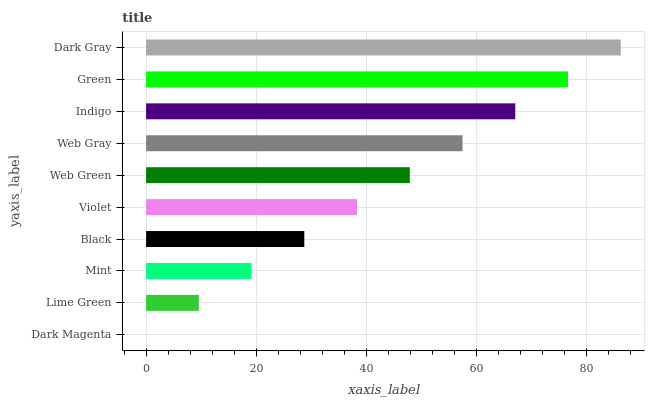Is Dark Magenta the minimum?
Answer yes or no. Yes. Is Dark Gray the maximum?
Answer yes or no. Yes. Is Lime Green the minimum?
Answer yes or no. No. Is Lime Green the maximum?
Answer yes or no. No. Is Lime Green greater than Dark Magenta?
Answer yes or no. Yes. Is Dark Magenta less than Lime Green?
Answer yes or no. Yes. Is Dark Magenta greater than Lime Green?
Answer yes or no. No. Is Lime Green less than Dark Magenta?
Answer yes or no. No. Is Web Green the high median?
Answer yes or no. Yes. Is Violet the low median?
Answer yes or no. Yes. Is Dark Magenta the high median?
Answer yes or no. No. Is Dark Gray the low median?
Answer yes or no. No. 